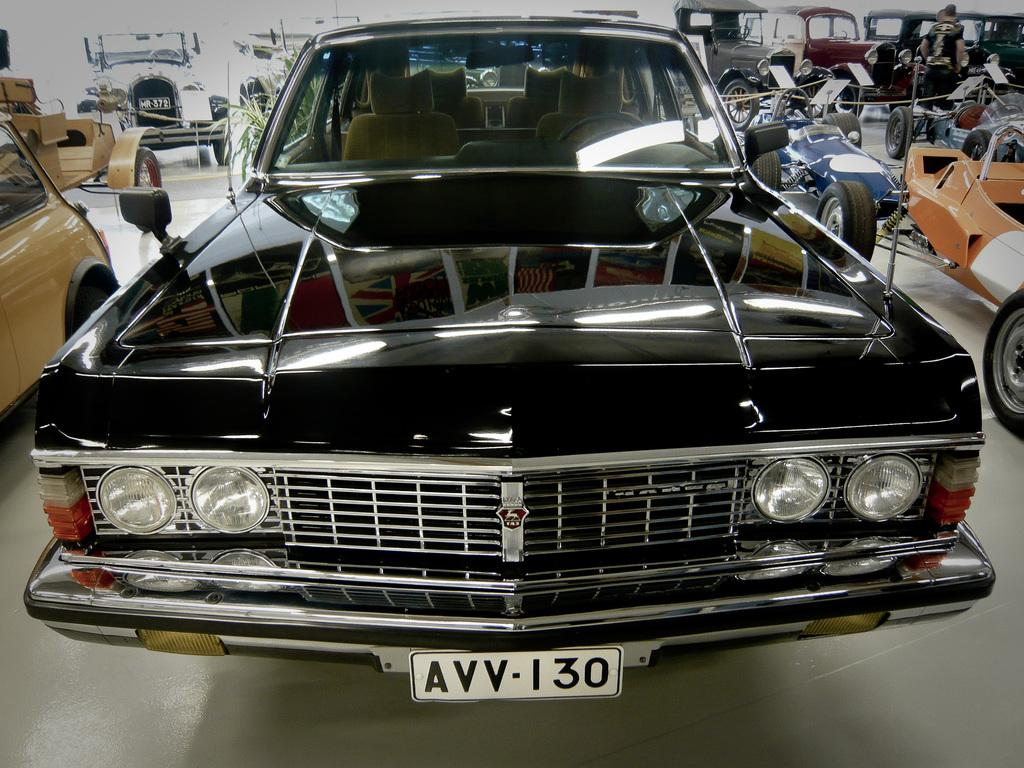What type of vehicles can be seen on the floor in the image? There are cars visible on the floor in the image. What is located on the left side of the image? There is a plant visible on the left side of the image. What is located on the right side of the image? There is a person visible on the right side of the image. What type of stitch is being used to sew the rail in the image? There is no rail or stitching present in the image. What type of feast is being prepared by the person on the right side of the image? There is no feast preparation visible in the image; only a person is present on the right side. 